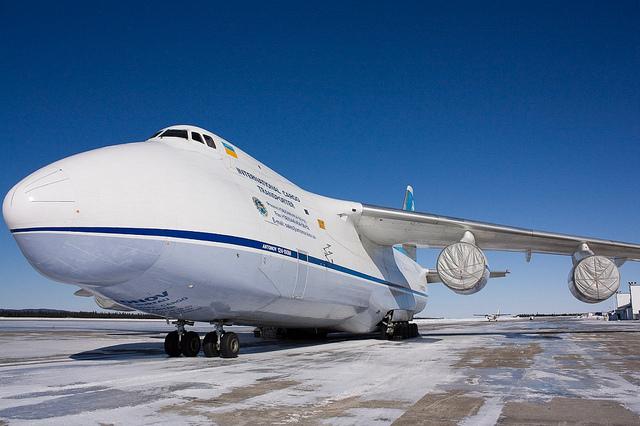What is covering the engines?
Keep it brief. Engine covers. Is the sky clear?
Concise answer only. Yes. Is the plane moving?
Concise answer only. No. 